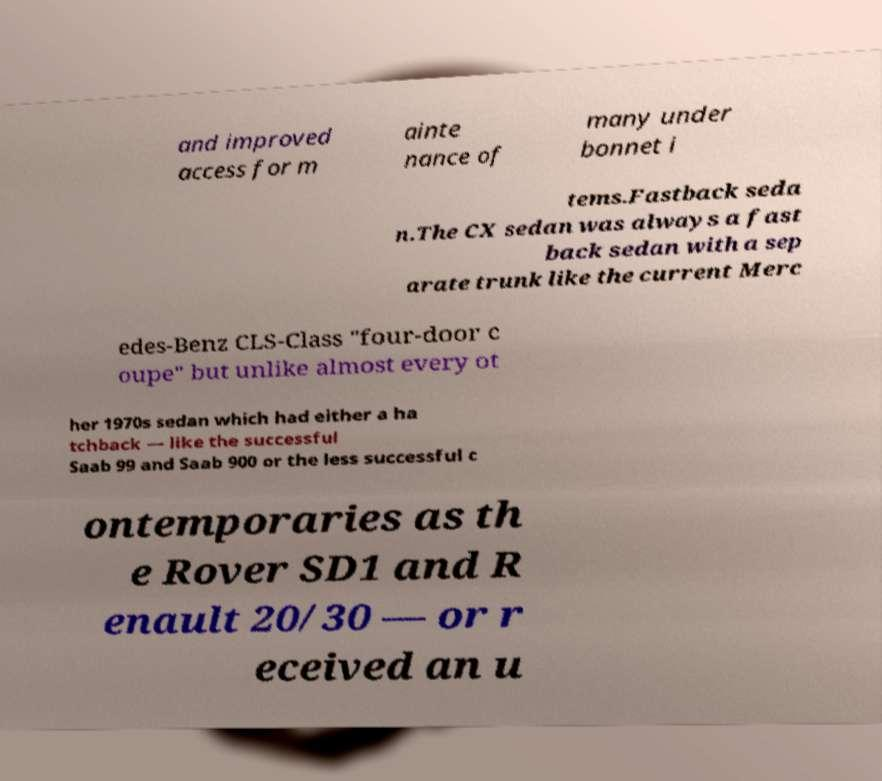I need the written content from this picture converted into text. Can you do that? and improved access for m ainte nance of many under bonnet i tems.Fastback seda n.The CX sedan was always a fast back sedan with a sep arate trunk like the current Merc edes-Benz CLS-Class "four-door c oupe" but unlike almost every ot her 1970s sedan which had either a ha tchback — like the successful Saab 99 and Saab 900 or the less successful c ontemporaries as th e Rover SD1 and R enault 20/30 — or r eceived an u 